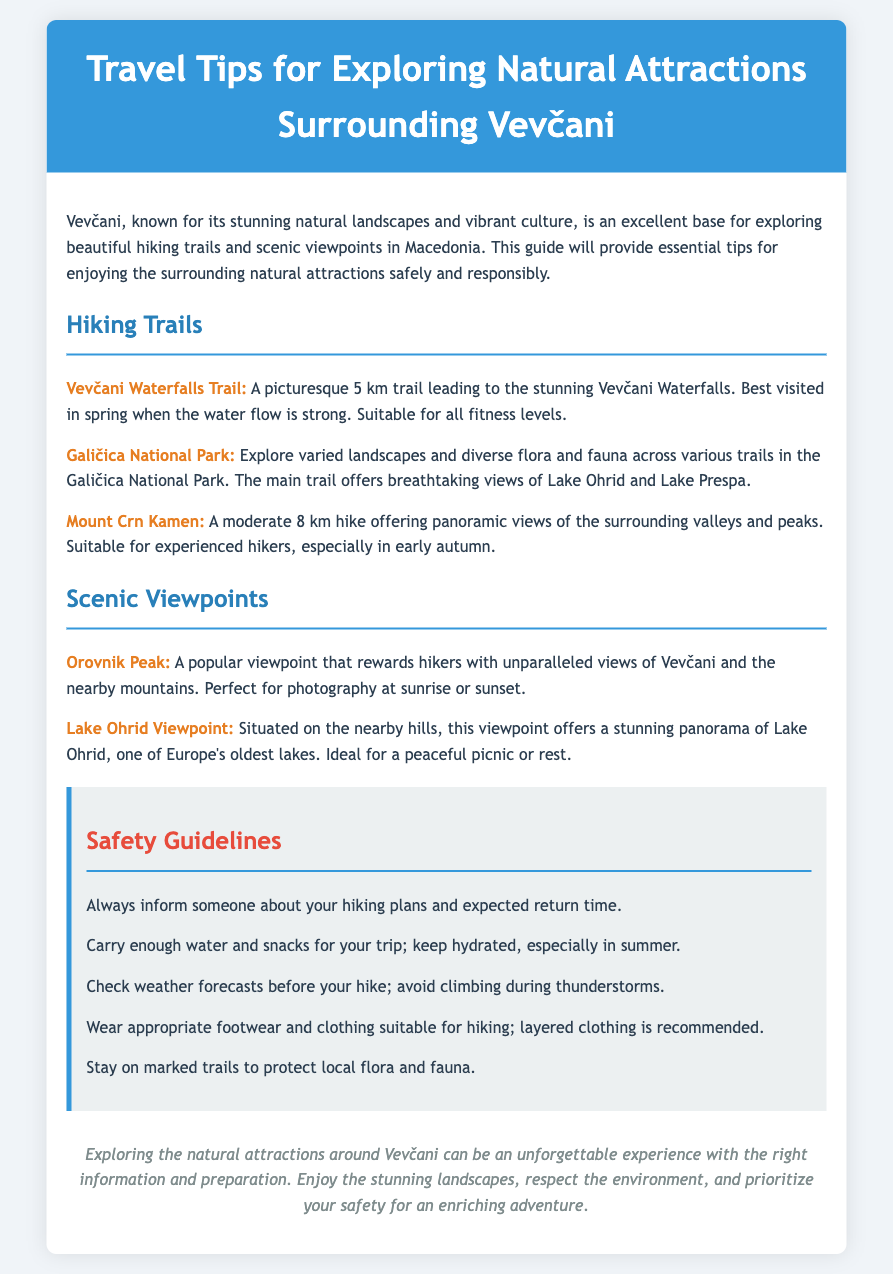What is the length of the Vevčani Waterfalls Trail? The document states that the Vevčani Waterfalls Trail is a picturesque 5 km trail.
Answer: 5 km What type of view does Orovnik Peak offer? The document mentions that Orovnik Peak rewards hikers with unparalleled views of Vevčani and the nearby mountains.
Answer: Unparalleled views Which park can you explore diverse flora and fauna? The document refers to Galičica National Park as a place to explore varied landscapes and diverse flora and fauna.
Answer: Galičica National Park What should hikers always inform someone about? The document advises that hikers should always inform someone about their hiking plans and expected return time.
Answer: Hiking plans What is recommended to wear for hiking? The document suggests wearing appropriate footwear and clothing suitable for hiking, specifically layered clothing.
Answer: Layered clothing What is the suggested time to visit the Vevčani Waterfalls? The document mentions that the best time to visit the Vevčani Waterfalls is in spring when the water flow is strong.
Answer: Spring How many safety guidelines are listed in the document? The document lists five safety guidelines for hikers.
Answer: Five What scenic activity is mentioned at the Lake Ohrid Viewpoint? The document states that the Lake Ohrid Viewpoint is ideal for a peaceful picnic or rest.
Answer: Picnic Which hiking trail is suitable for experienced hikers? The document indicates that the Mount Crn Kamen trail is suitable for experienced hikers.
Answer: Mount Crn Kamen 